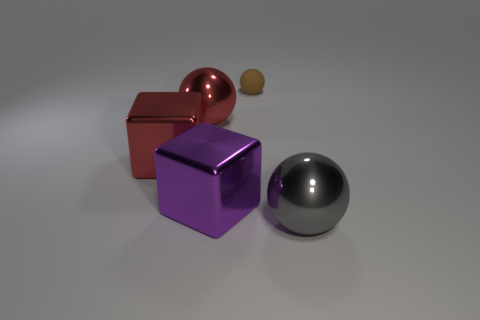Imagine these objects were part of a video game, what could their functions be? The red metallic cube might serve as a puzzle element that interacts with other components or machinery. The purple cube could be a collectible item for points or energy, and the small brown sphere may be a token for unlocking new game levels or as part of a crafting resource. Could they represent different powers or abilities? Certainly, the red metallic cube could symbolize strength or endurance, the purple cube might imply wisdom or magic, and the small brown sphere could grant the player stealth or speed due to its smaller size and less conspicuous color. 